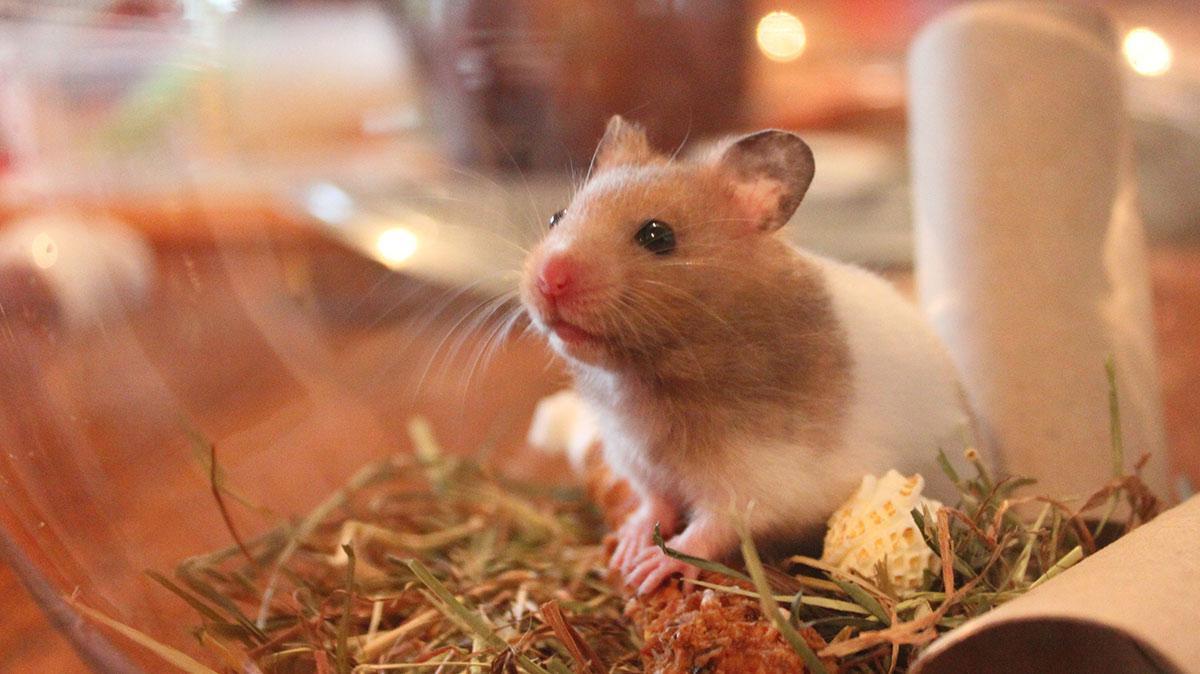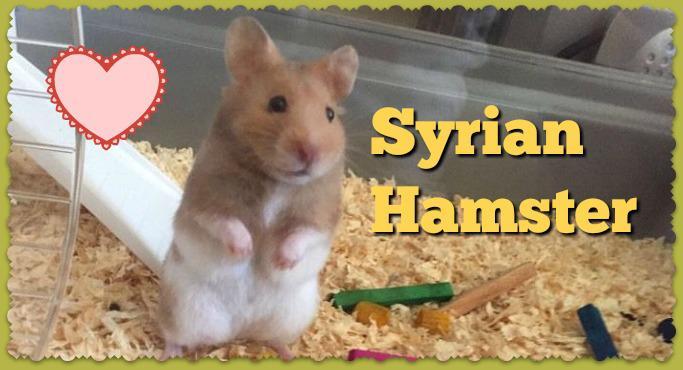The first image is the image on the left, the second image is the image on the right. For the images shown, is this caption "An image contains two hamsters and some part of a human." true? Answer yes or no. No. The first image is the image on the left, the second image is the image on the right. Considering the images on both sides, is "A hamster is standing on its hind legs with its front legs up and not touching the ground." valid? Answer yes or no. Yes. 